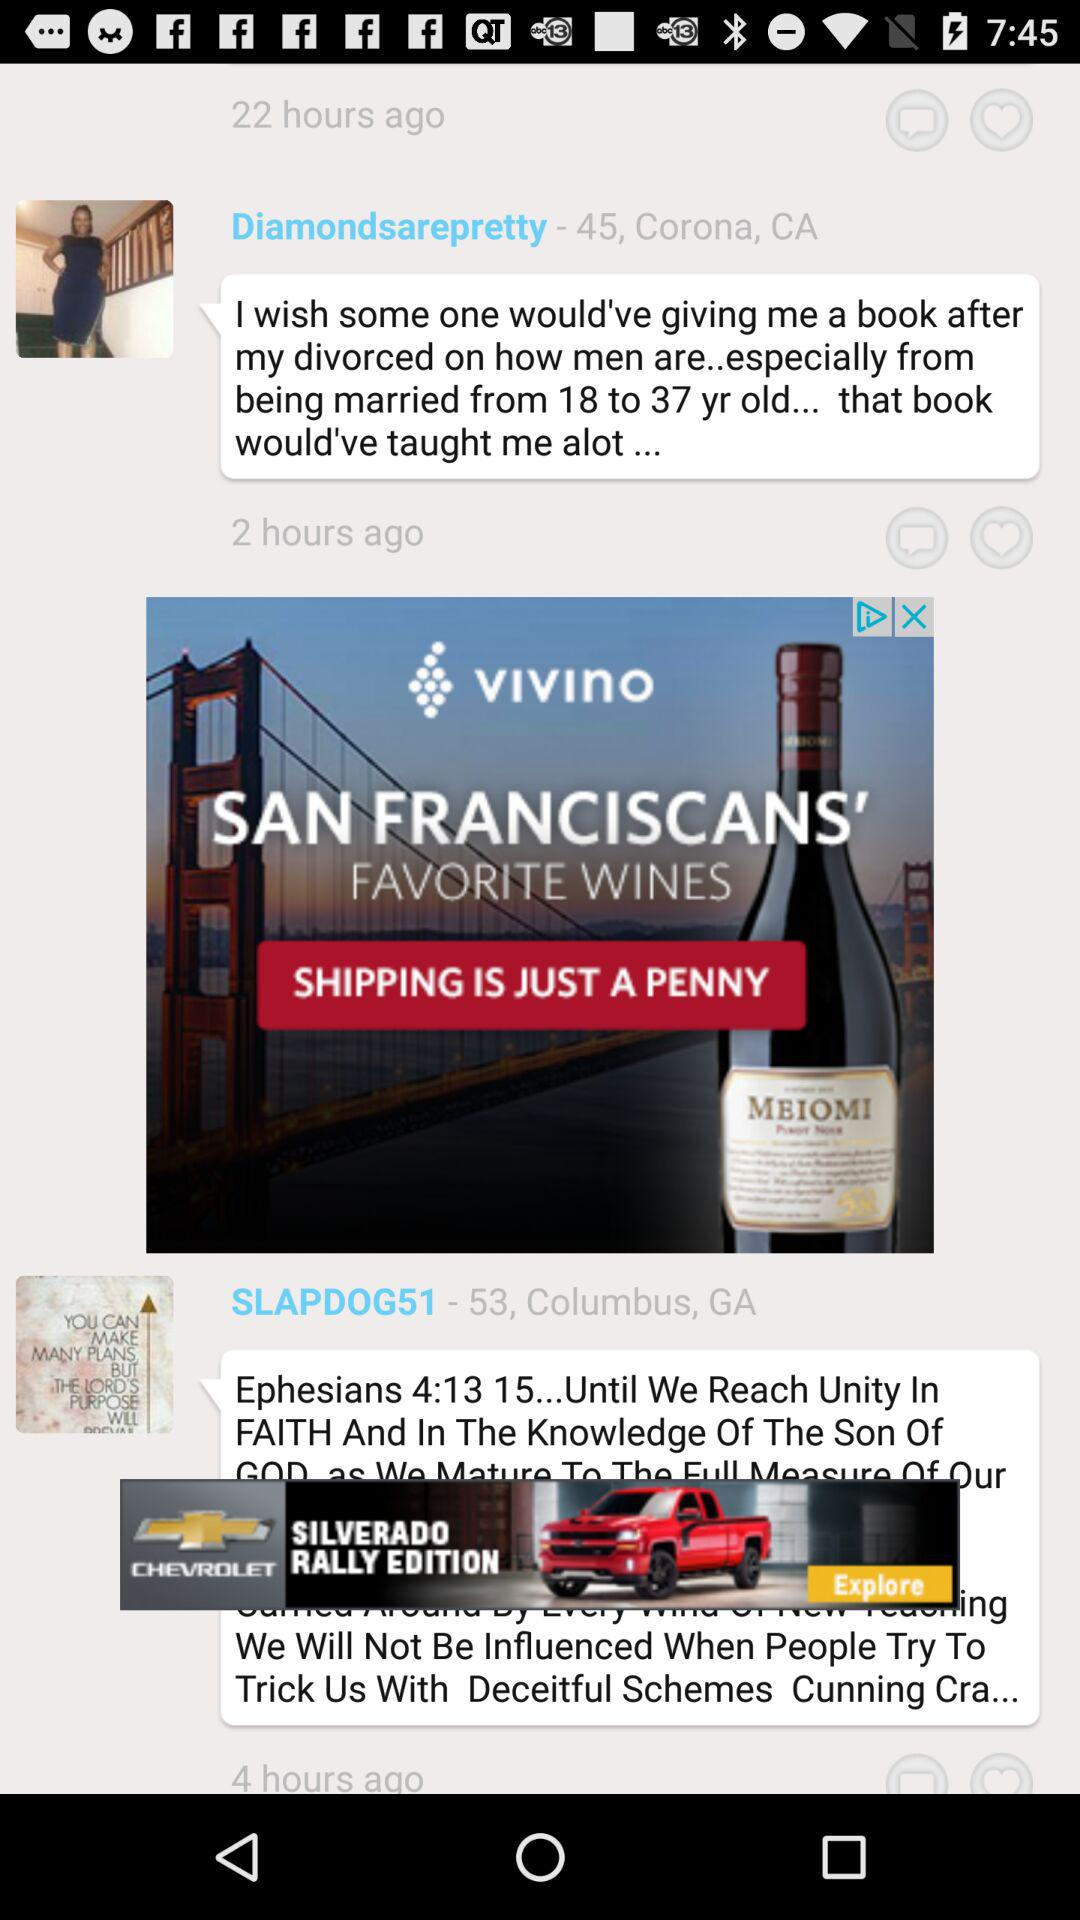How many hours ago did "Diamondsarepretty" post? "Diamondsarepretty" posted 2 hours ago. 